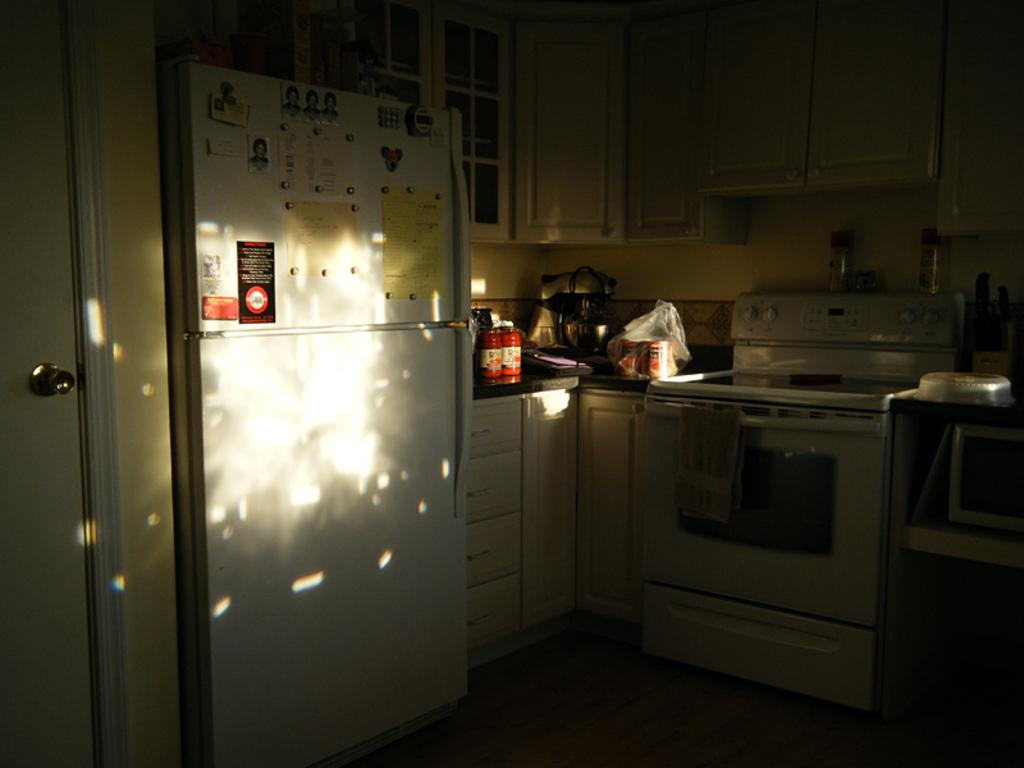What type of appliance is visible in the image? There is a refrigerator in the image. What other kitchen fixtures can be seen in the image? There are cupboards and a stove in the image. What is on the platform in the image? There are objects on a platform in the image. What feature of the room is visible in the image? There is a door in the image. What type of plants are growing inside the refrigerator in the image? There are no plants visible inside the refrigerator in the image. What color is the stocking hanging on the stove in the image? There is no stocking present on the stove in the image. 